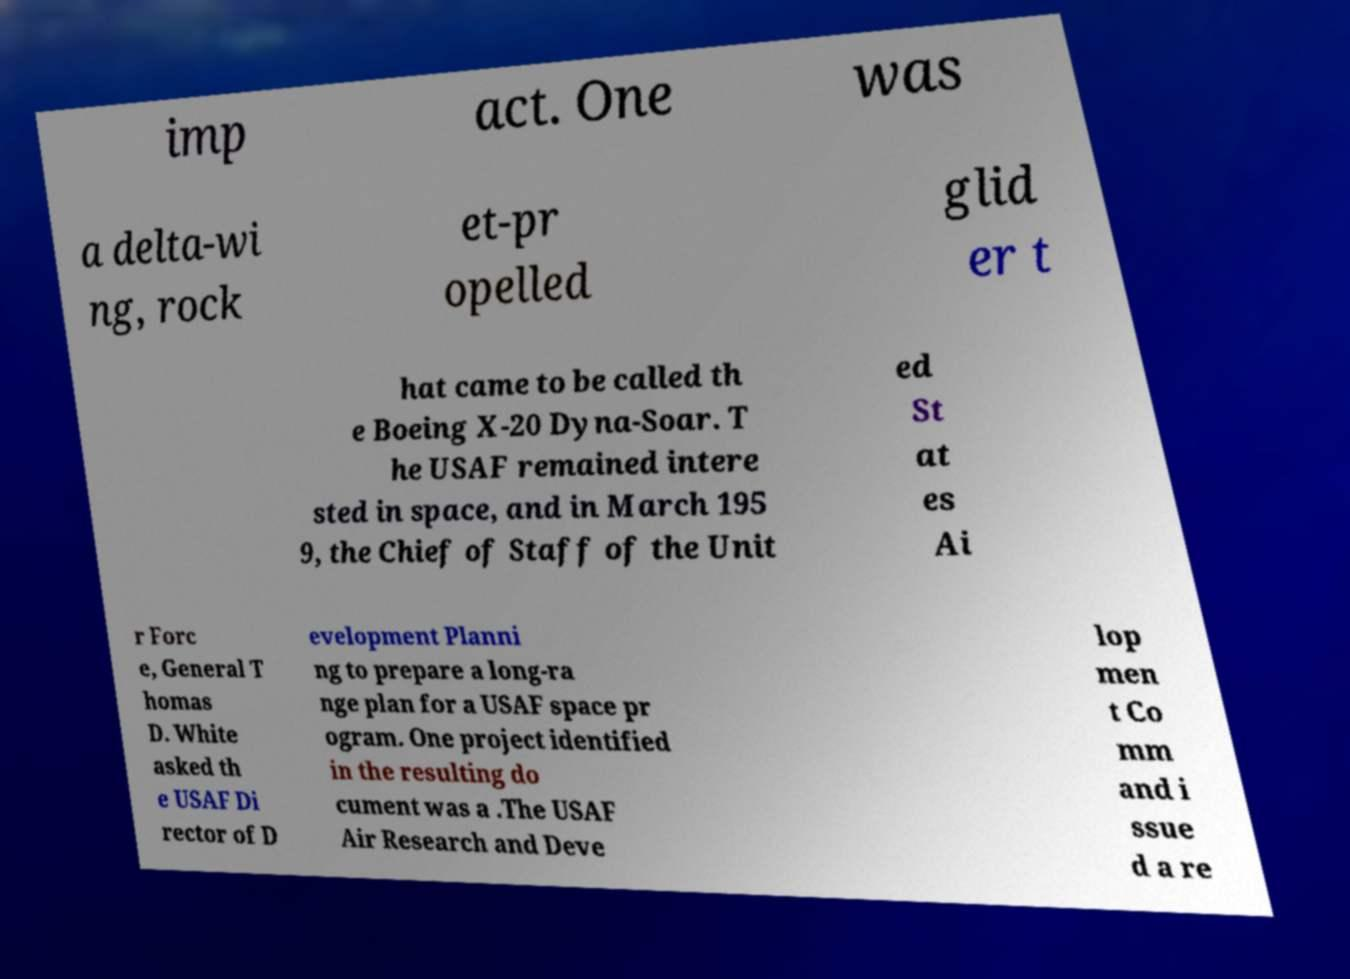I need the written content from this picture converted into text. Can you do that? imp act. One was a delta-wi ng, rock et-pr opelled glid er t hat came to be called th e Boeing X-20 Dyna-Soar. T he USAF remained intere sted in space, and in March 195 9, the Chief of Staff of the Unit ed St at es Ai r Forc e, General T homas D. White asked th e USAF Di rector of D evelopment Planni ng to prepare a long-ra nge plan for a USAF space pr ogram. One project identified in the resulting do cument was a .The USAF Air Research and Deve lop men t Co mm and i ssue d a re 